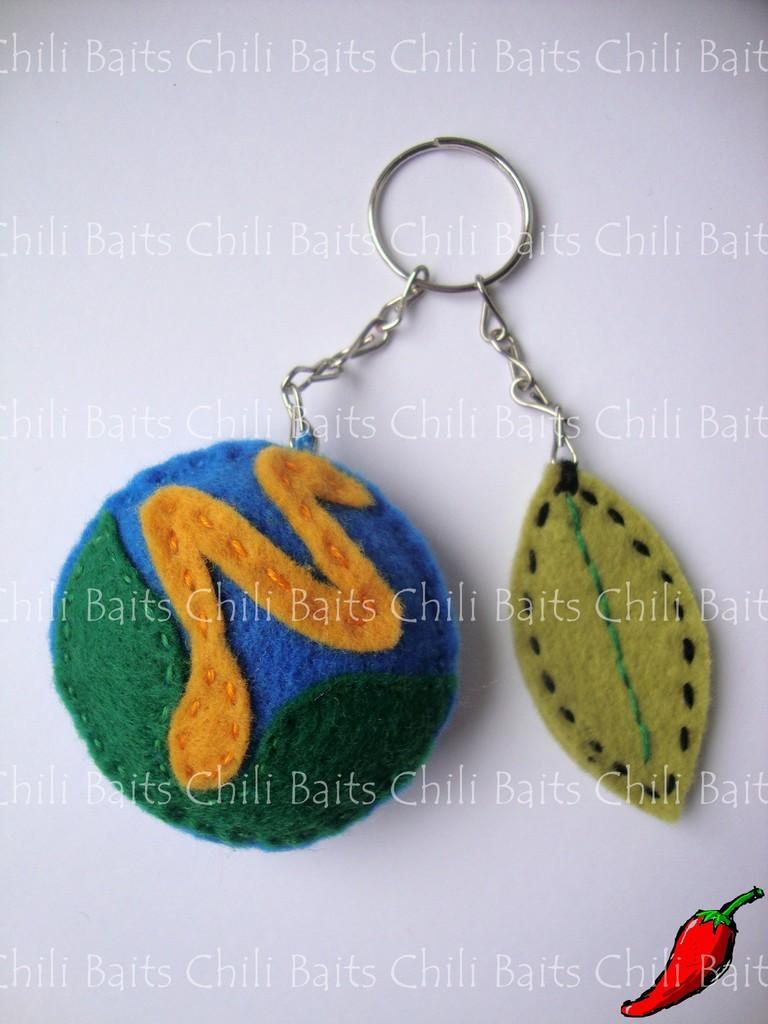How would you summarize this image in a sentence or two? In the center of the image, we can see a keychain and there is some text and we can see a logo. 